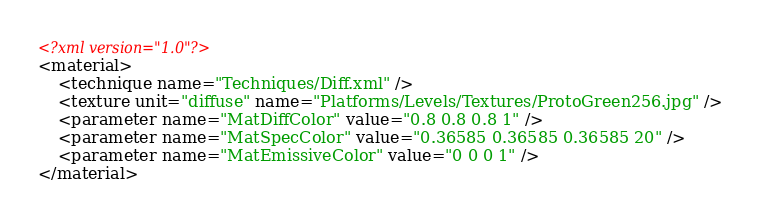<code> <loc_0><loc_0><loc_500><loc_500><_XML_><?xml version="1.0"?>
<material>
	<technique name="Techniques/Diff.xml" />
	<texture unit="diffuse" name="Platforms/Levels/Textures/ProtoGreen256.jpg" />
	<parameter name="MatDiffColor" value="0.8 0.8 0.8 1" />
	<parameter name="MatSpecColor" value="0.36585 0.36585 0.36585 20" />
	<parameter name="MatEmissiveColor" value="0 0 0 1" />
</material>
</code> 